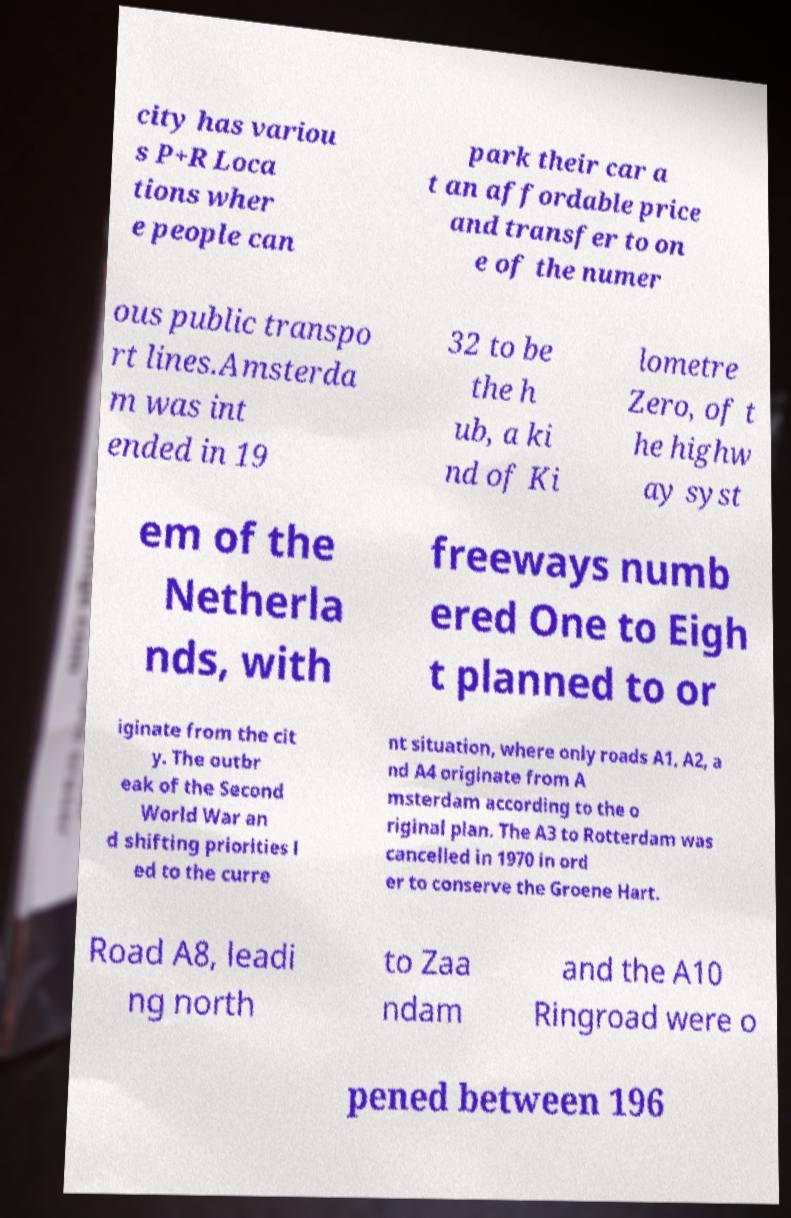Could you assist in decoding the text presented in this image and type it out clearly? city has variou s P+R Loca tions wher e people can park their car a t an affordable price and transfer to on e of the numer ous public transpo rt lines.Amsterda m was int ended in 19 32 to be the h ub, a ki nd of Ki lometre Zero, of t he highw ay syst em of the Netherla nds, with freeways numb ered One to Eigh t planned to or iginate from the cit y. The outbr eak of the Second World War an d shifting priorities l ed to the curre nt situation, where only roads A1, A2, a nd A4 originate from A msterdam according to the o riginal plan. The A3 to Rotterdam was cancelled in 1970 in ord er to conserve the Groene Hart. Road A8, leadi ng north to Zaa ndam and the A10 Ringroad were o pened between 196 